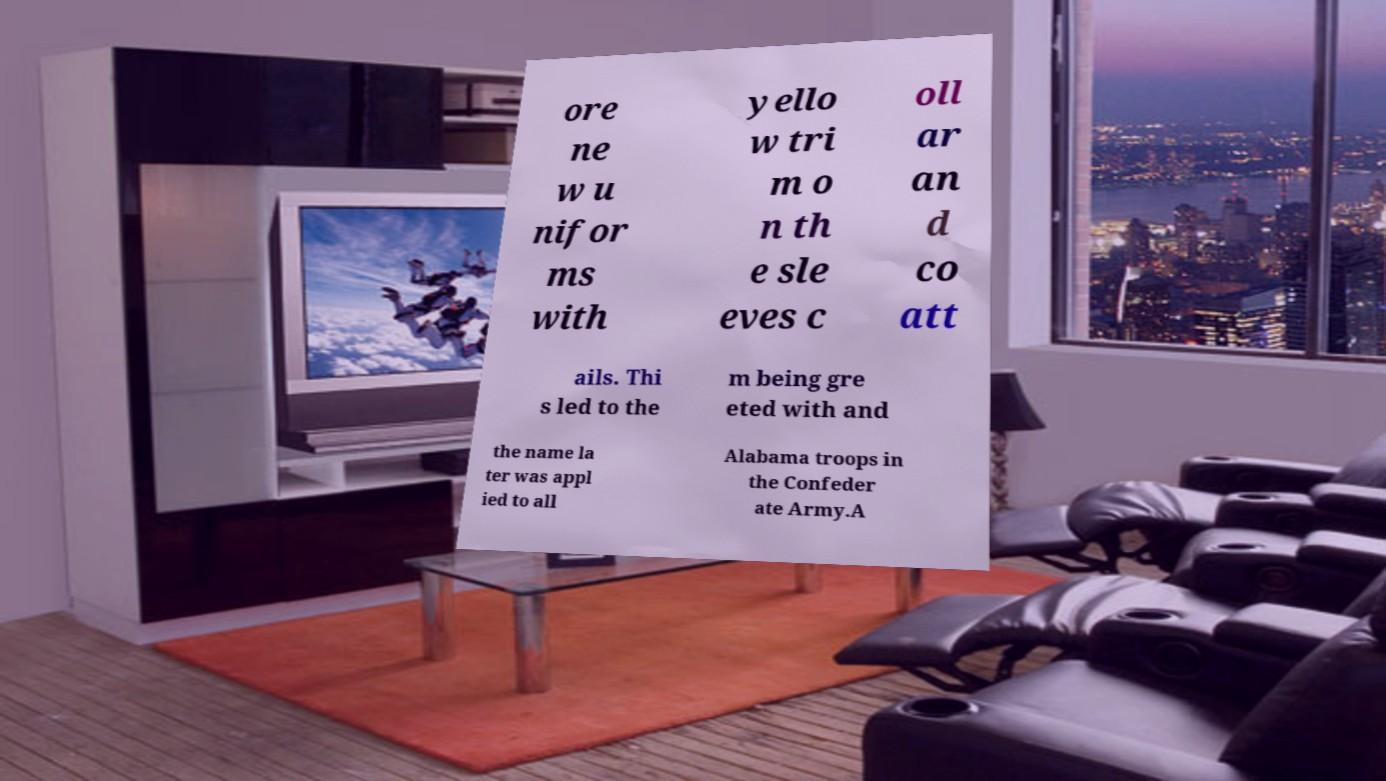I need the written content from this picture converted into text. Can you do that? ore ne w u nifor ms with yello w tri m o n th e sle eves c oll ar an d co att ails. Thi s led to the m being gre eted with and the name la ter was appl ied to all Alabama troops in the Confeder ate Army.A 